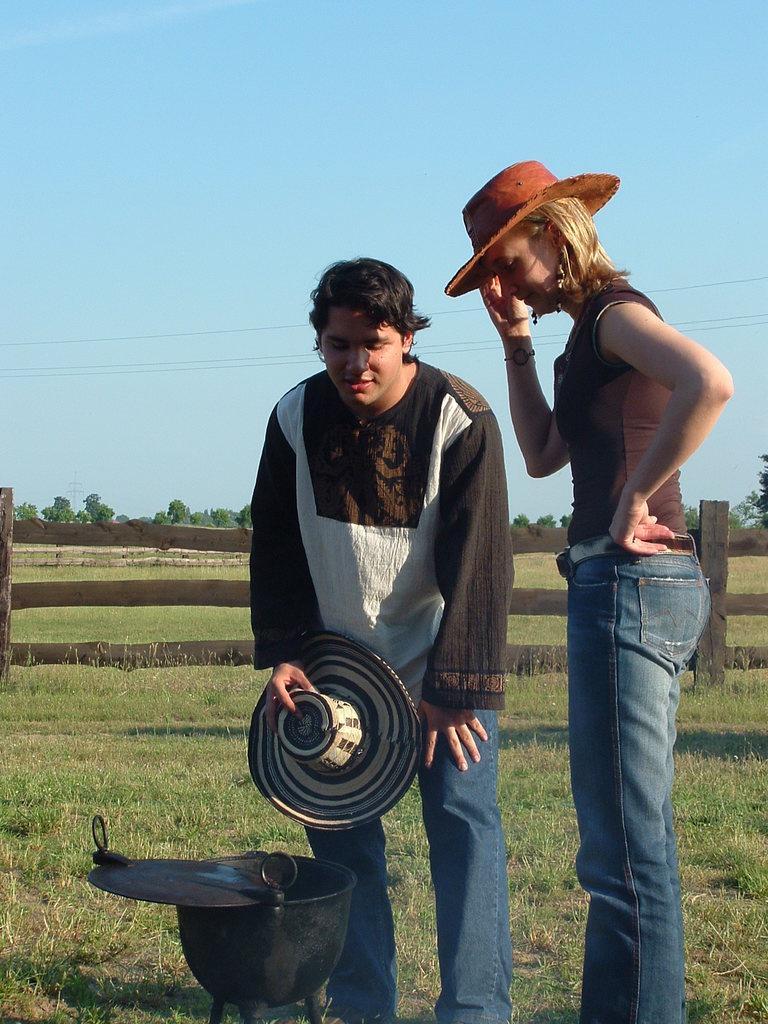Describe this image in one or two sentences. In the foreground of the picture there is a man and a woman standing, woman is wearing a hat. The man is holding a cap. In front of them there is a bowl. This is a picture taken in a field, in the field there are shrubs, grass, fencing. In the background there are trees and fields. Sky is clear. In the center of the background there are cables. It is sunny. 